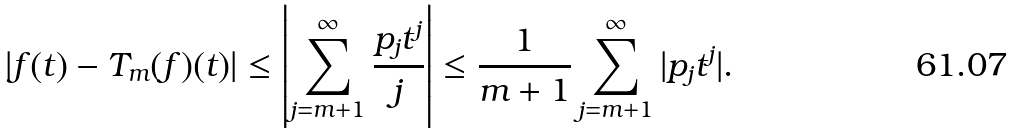Convert formula to latex. <formula><loc_0><loc_0><loc_500><loc_500>| f ( t ) - T _ { m } ( f ) ( t ) | \leq \left | \sum _ { j = m + 1 } ^ { \infty } \frac { p _ { j } t ^ { j } } { j } \right | \leq \frac { 1 } { m + 1 } \sum _ { j = m + 1 } ^ { \infty } | p _ { j } t ^ { j } | .</formula> 